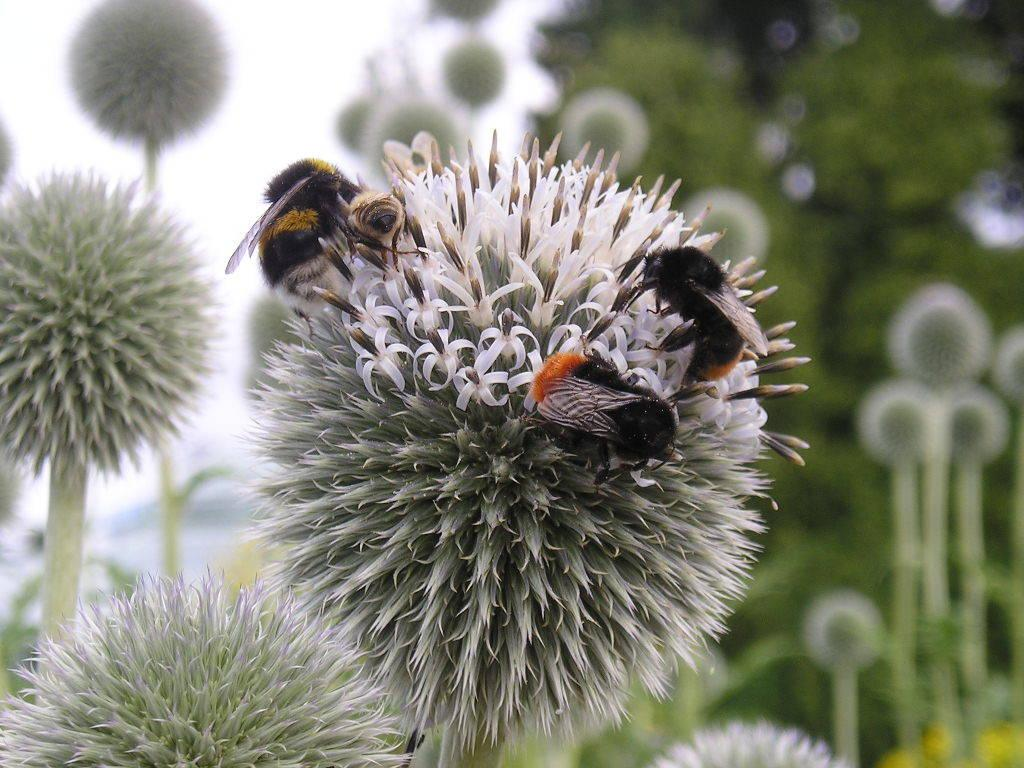What type of flowers can be seen in the image? There are white color flowers in the image. Are there any other living organisms present on the flowers? Yes, there are insects on the flowers. What colors are predominant in the background of the image? The background is green and white in color. How is the background of the image depicted? The background is blurred. Can you see any dinosaurs eating an apple in the image? No, there are no dinosaurs or apples present in the image. 